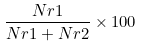<formula> <loc_0><loc_0><loc_500><loc_500>\frac { N r 1 } { N r 1 + N r 2 } \times 1 0 0</formula> 